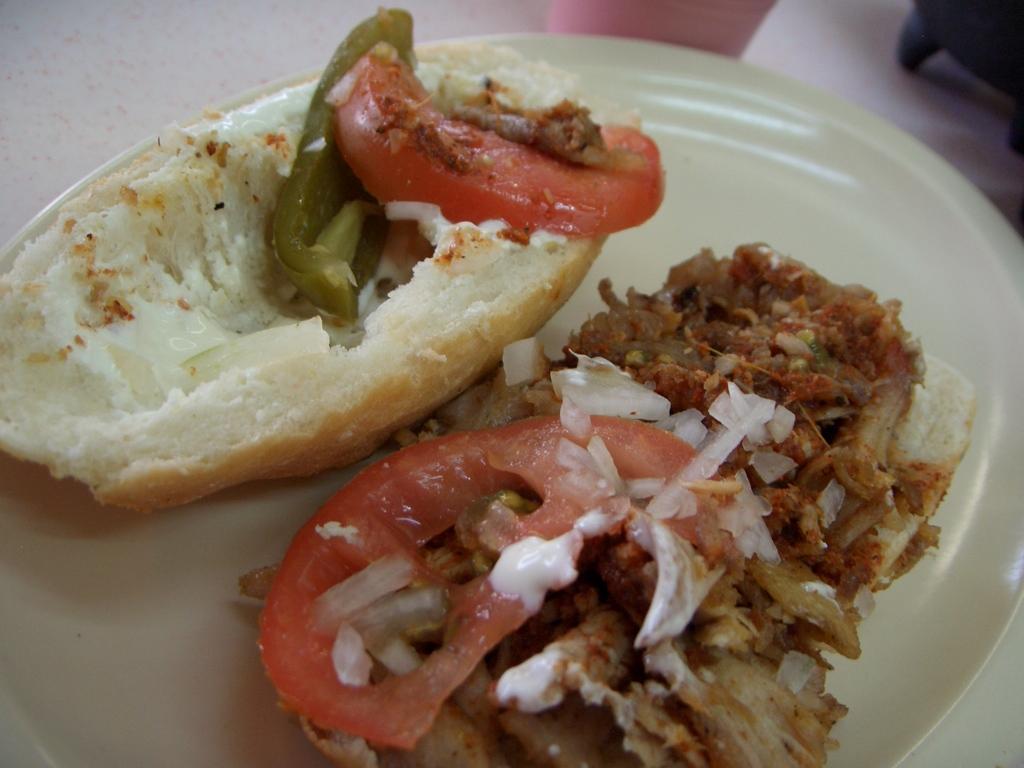How would you summarize this image in a sentence or two? In this image we can see food item in a white color plate. 